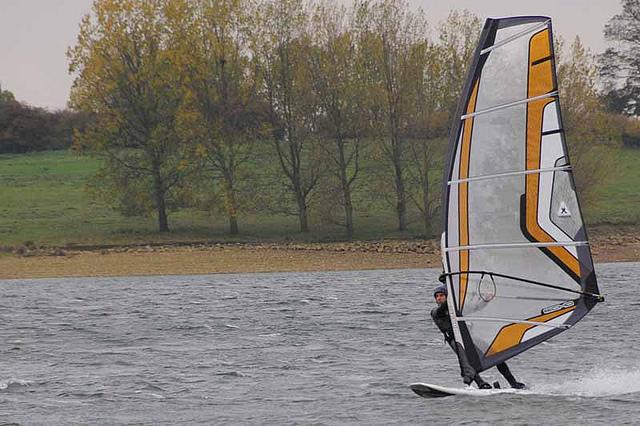Is the man on a surfboard?
Concise answer only. Yes. Is windsurfing hard?
Be succinct. Yes. Is it going to rain?
Answer briefly. Yes. 